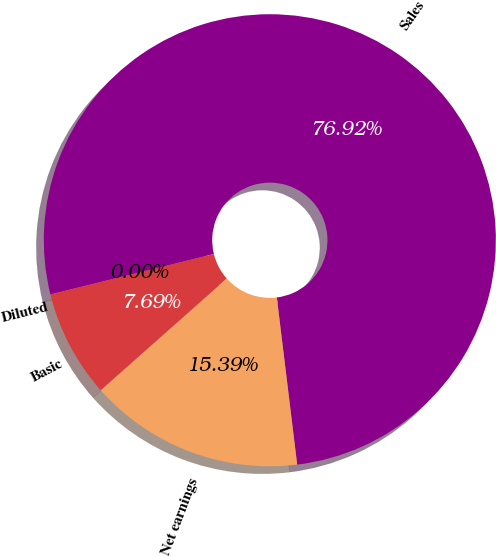<chart> <loc_0><loc_0><loc_500><loc_500><pie_chart><fcel>Sales<fcel>Net earnings<fcel>Basic<fcel>Diluted<nl><fcel>76.92%<fcel>15.39%<fcel>7.69%<fcel>0.0%<nl></chart> 